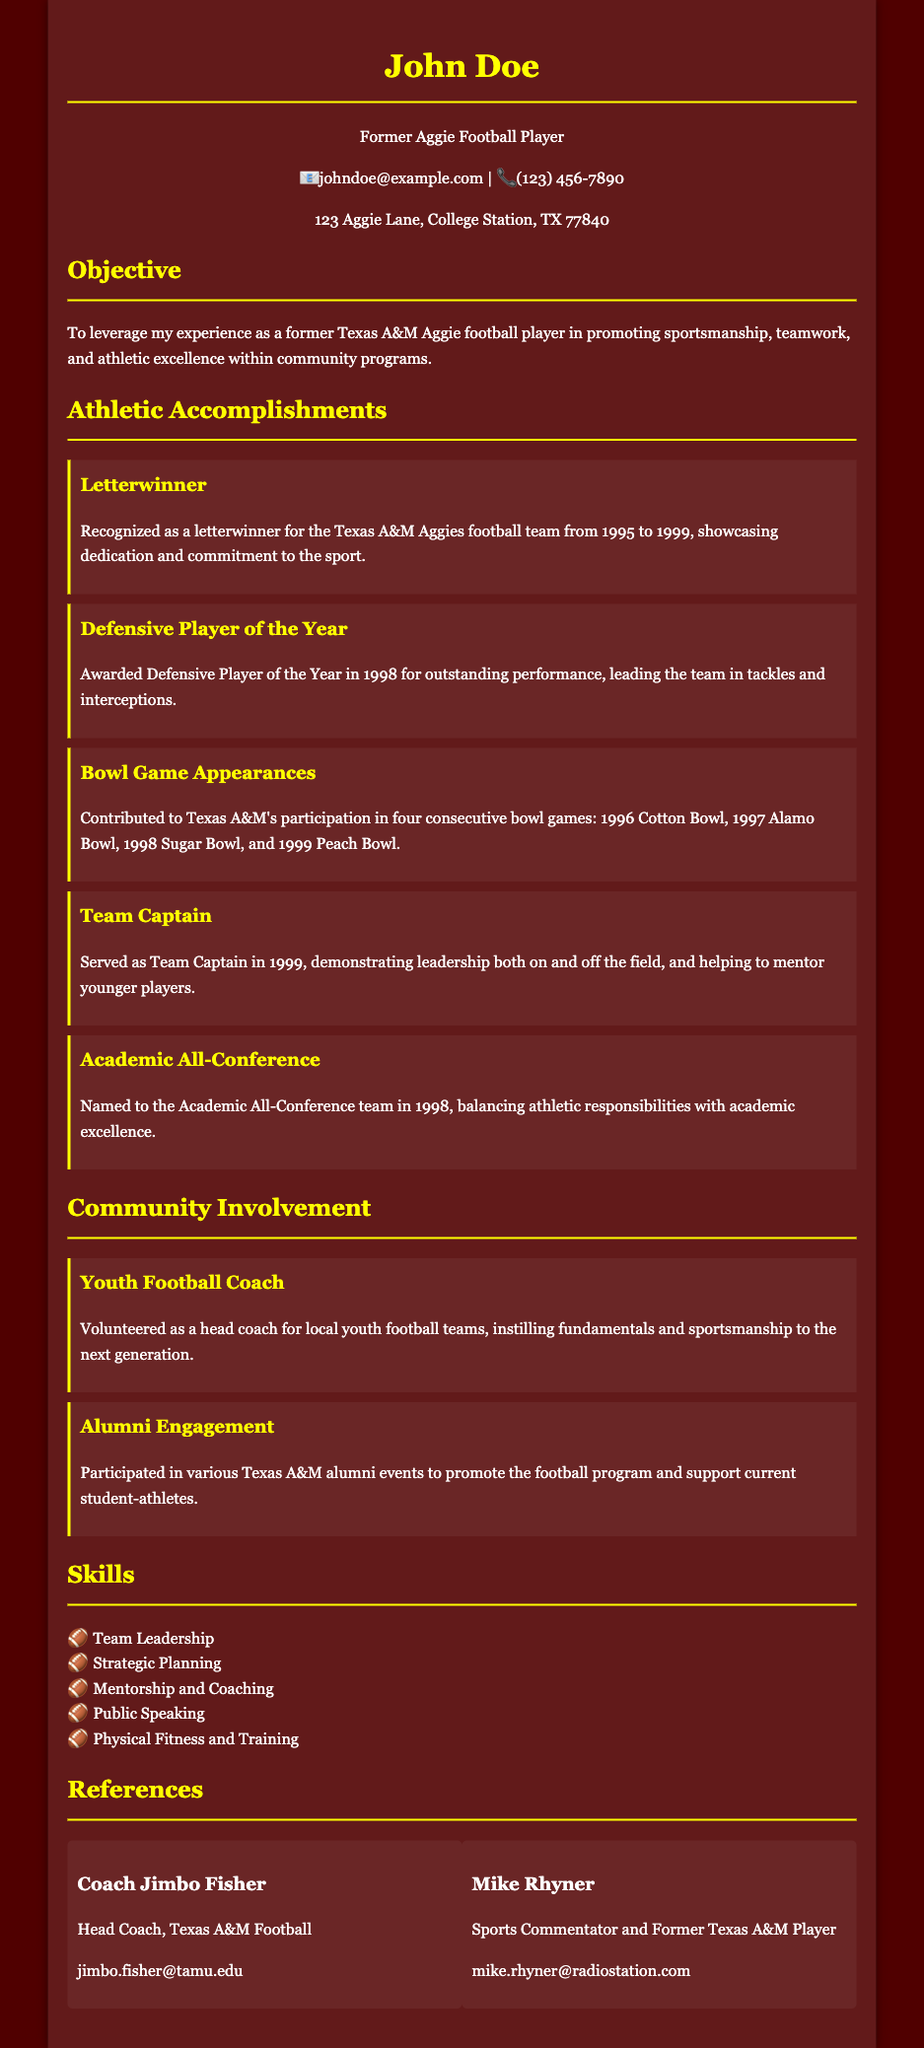What years was John Doe a letterwinner? John Doe was a letterwinner for the Texas A&M Aggies football team from 1995 to 1999.
Answer: 1995 to 1999 What award did John Doe receive in 1998? John Doe was awarded Defensive Player of the Year in 1998 for outstanding performance.
Answer: Defensive Player of the Year How many bowl games did John Doe contribute to? John Doe contributed to Texas A&M's participation in four consecutive bowl games during his time.
Answer: Four What position did John Doe serve in 1999? In 1999, John Doe served as Team Captain, demonstrating leadership on the field.
Answer: Team Captain What honors did John Doe achieve in 1998 besides playing? In addition to playing, John Doe was named to the Academic All-Conference team in 1998.
Answer: Academic All-Conference What type of volunteer work has John Doe done? John Doe volunteered as a head coach for local youth football teams.
Answer: Head coach Who is listed as a reference from Texas A&M Football? The document lists Coach Jimbo Fisher as a reference from Texas A&M Football.
Answer: Coach Jimbo Fisher In what year did John Doe participate in the Cotton Bowl? John Doe contributed to Texas A&M's participation in the Cotton Bowl in 1996.
Answer: 1996 What skill is highlighted in John Doe's CV? Team Leadership is one of the skills highlighted in John Doe's CV.
Answer: Team Leadership 